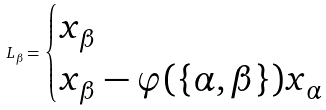<formula> <loc_0><loc_0><loc_500><loc_500>L _ { \beta } = \begin{cases} x _ { \beta } & \\ x _ { \beta } - \varphi ( \{ \alpha , \beta \} ) x _ { \alpha } & \end{cases}</formula> 